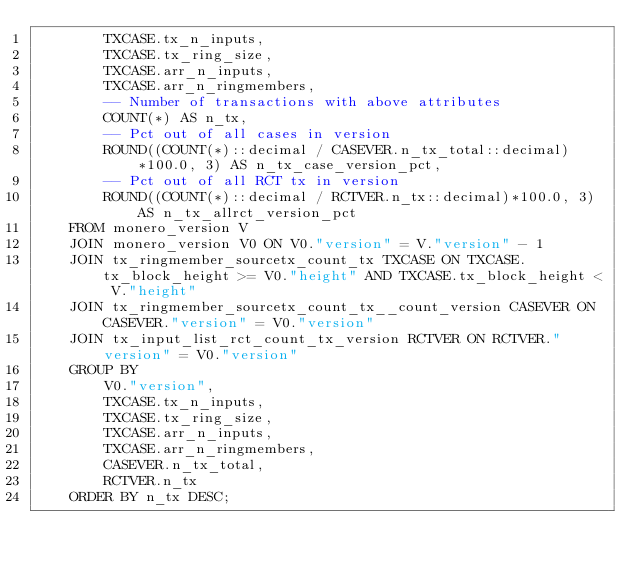<code> <loc_0><loc_0><loc_500><loc_500><_SQL_>        TXCASE.tx_n_inputs,
        TXCASE.tx_ring_size,
        TXCASE.arr_n_inputs,
        TXCASE.arr_n_ringmembers,
        -- Number of transactions with above attributes
        COUNT(*) AS n_tx,
        -- Pct out of all cases in version
        ROUND((COUNT(*)::decimal / CASEVER.n_tx_total::decimal)*100.0, 3) AS n_tx_case_version_pct,
        -- Pct out of all RCT tx in version
        ROUND((COUNT(*)::decimal / RCTVER.n_tx::decimal)*100.0, 3) AS n_tx_allrct_version_pct
    FROM monero_version V
    JOIN monero_version V0 ON V0."version" = V."version" - 1
    JOIN tx_ringmember_sourcetx_count_tx TXCASE ON TXCASE.tx_block_height >= V0."height" AND TXCASE.tx_block_height < V."height"
    JOIN tx_ringmember_sourcetx_count_tx__count_version CASEVER ON CASEVER."version" = V0."version"
    JOIN tx_input_list_rct_count_tx_version RCTVER ON RCTVER."version" = V0."version"
    GROUP BY 
        V0."version",
        TXCASE.tx_n_inputs,
        TXCASE.tx_ring_size,
        TXCASE.arr_n_inputs,
        TXCASE.arr_n_ringmembers,
        CASEVER.n_tx_total,
        RCTVER.n_tx
    ORDER BY n_tx DESC;</code> 